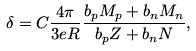Convert formula to latex. <formula><loc_0><loc_0><loc_500><loc_500>\delta = C \frac { 4 \pi } { 3 e R } \frac { b _ { p } M _ { p } + b _ { n } M _ { n } } { b _ { p } Z + b _ { n } N } ,</formula> 